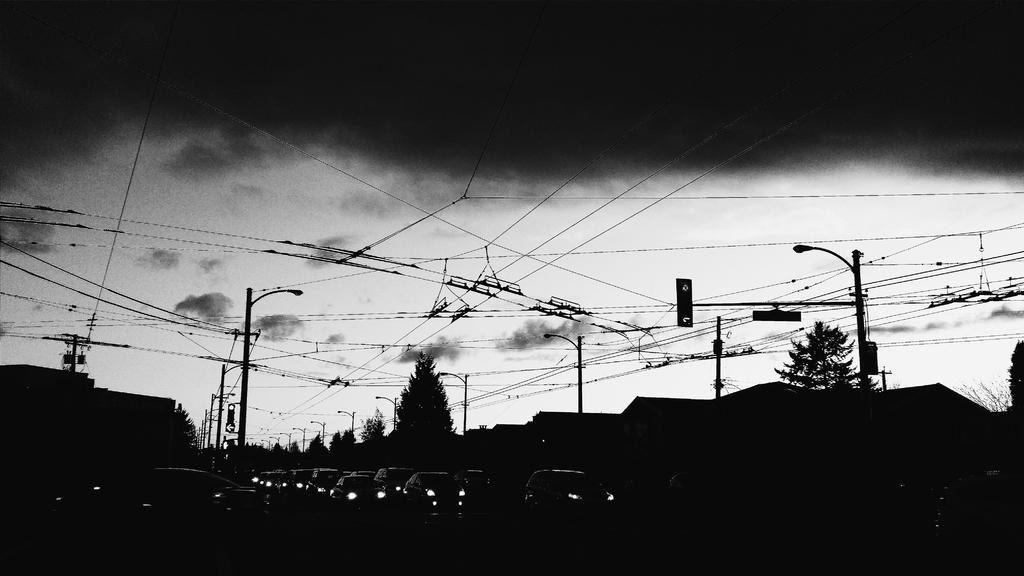What type of vehicles can be seen in the image? There are cars in the image. What type of natural elements are present in the image? There are trees in the image. What type of structures can be seen in the image? There are houses in the image. What type of man-made objects are present in the image? There are poles in the image. Where are the houses, cars, trees, and poles located in the image? The houses, cars, trees, and poles are located at the bottom side of the image. What is in the center of the image? There are wires in the center of the image. What type of soup is being served in the prison in the image? There is no soup or prison present in the image. What type of health benefits can be gained from the trees in the image? The image does not provide information about the health benefits of the trees. 